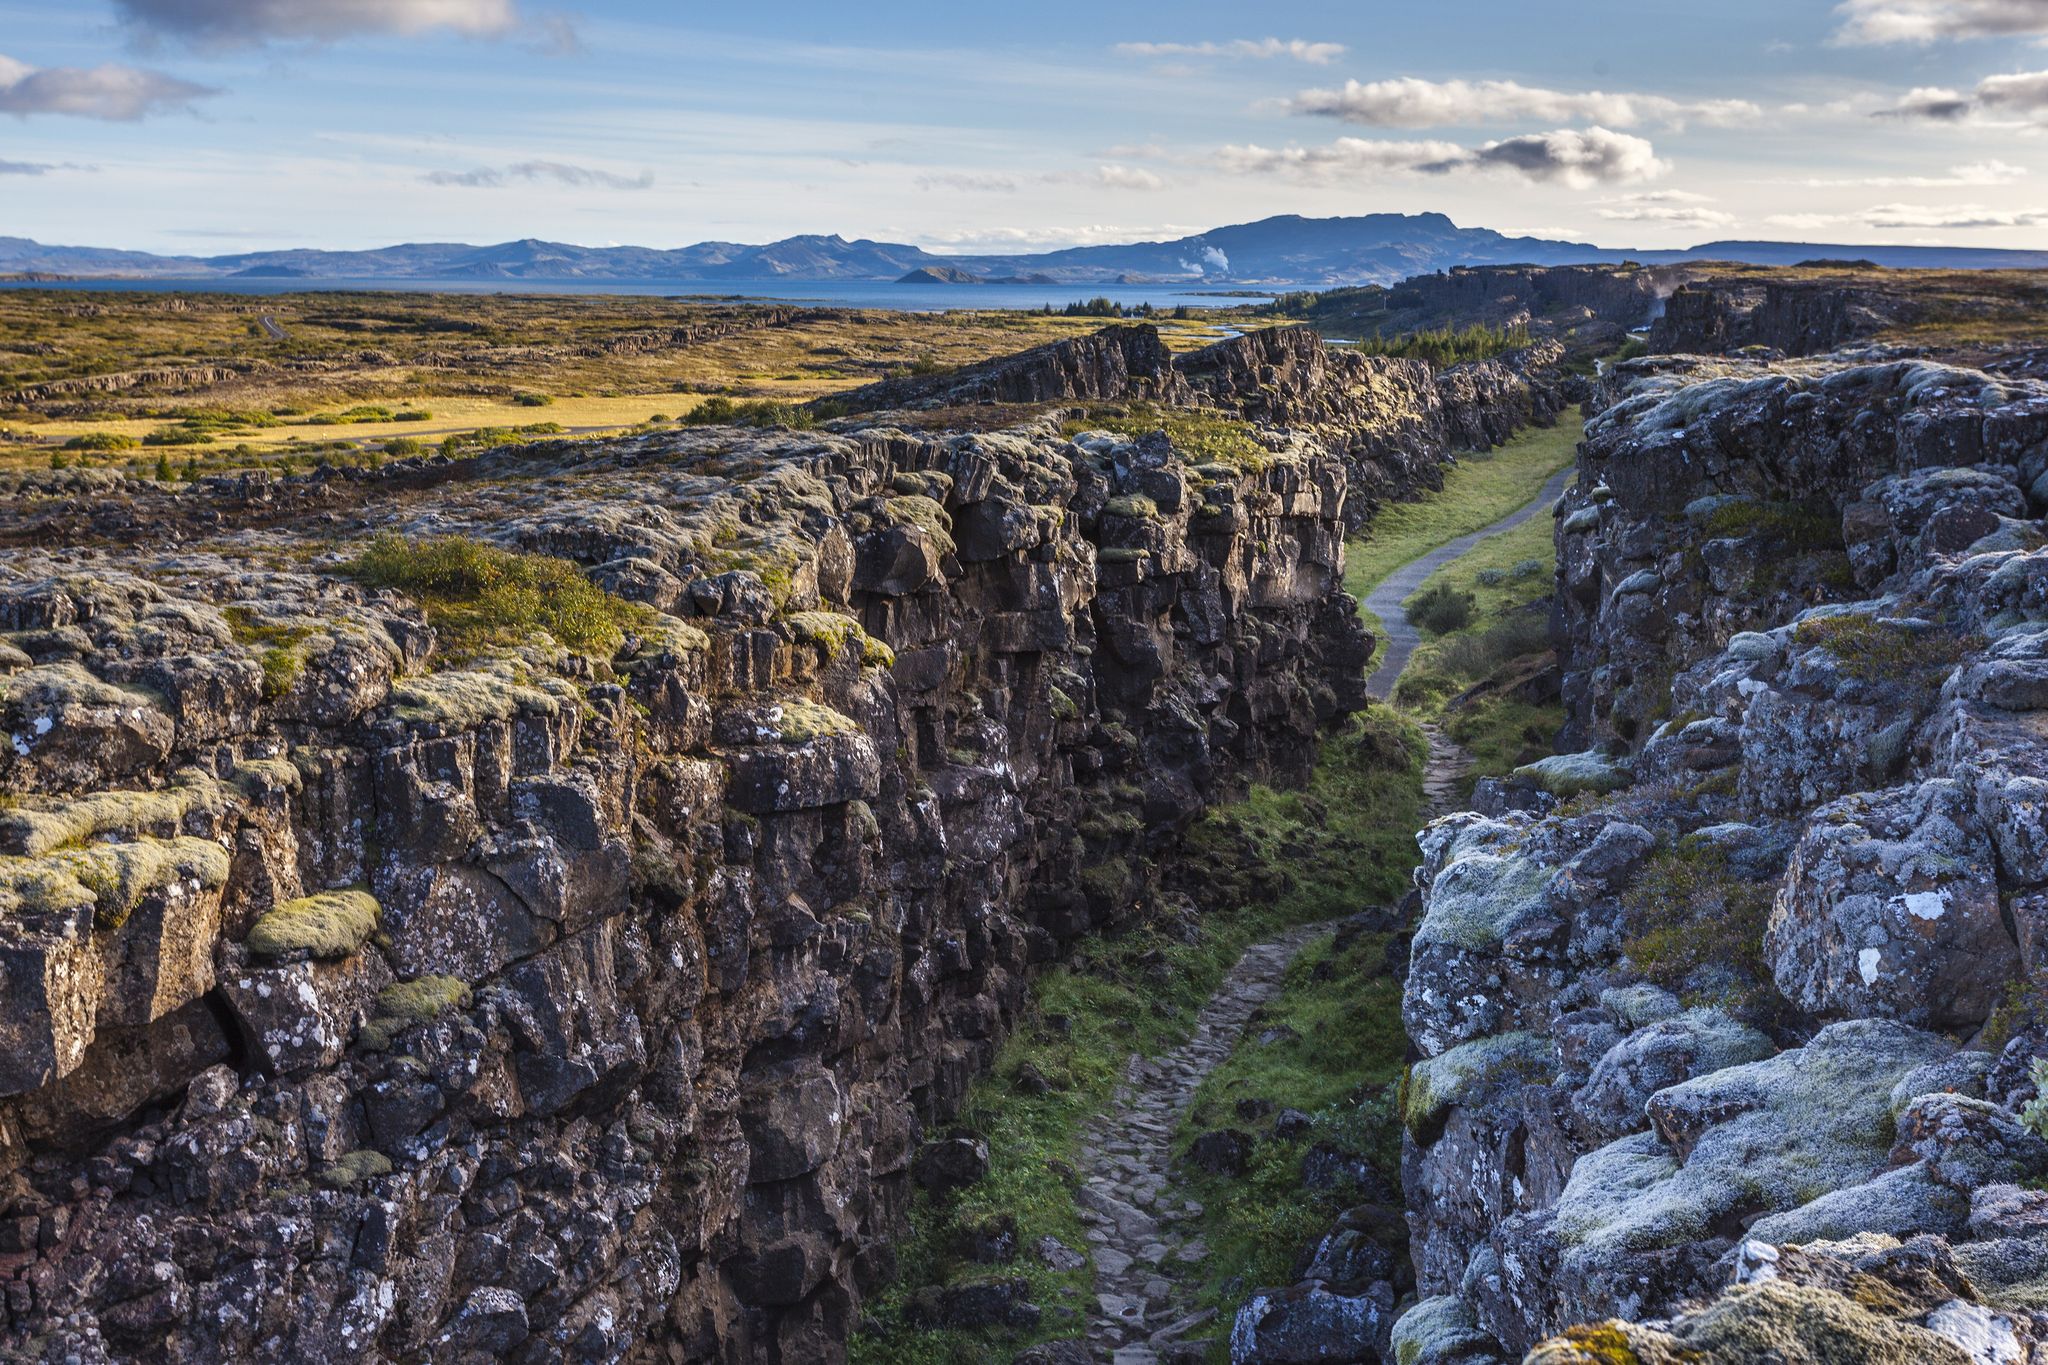If you could explore any path in Þingvellir National Park, where would you go and why? If I had the opportunity to explore any path in Þingvellir National Park, I would choose to follow the path within Almannagjá gorge. This path allows you to walk between the North American and Eurasian tectonic plates, offering a unique experience of being in the midst of such significant geological processes. The sheer cliffs, covered in moss and lichen, provide a picturesque and serene environment. Along the way, one can also explore historical sites, adding to the enriched experience of witnessing both natural beauty and cultural heritage in one trail. 